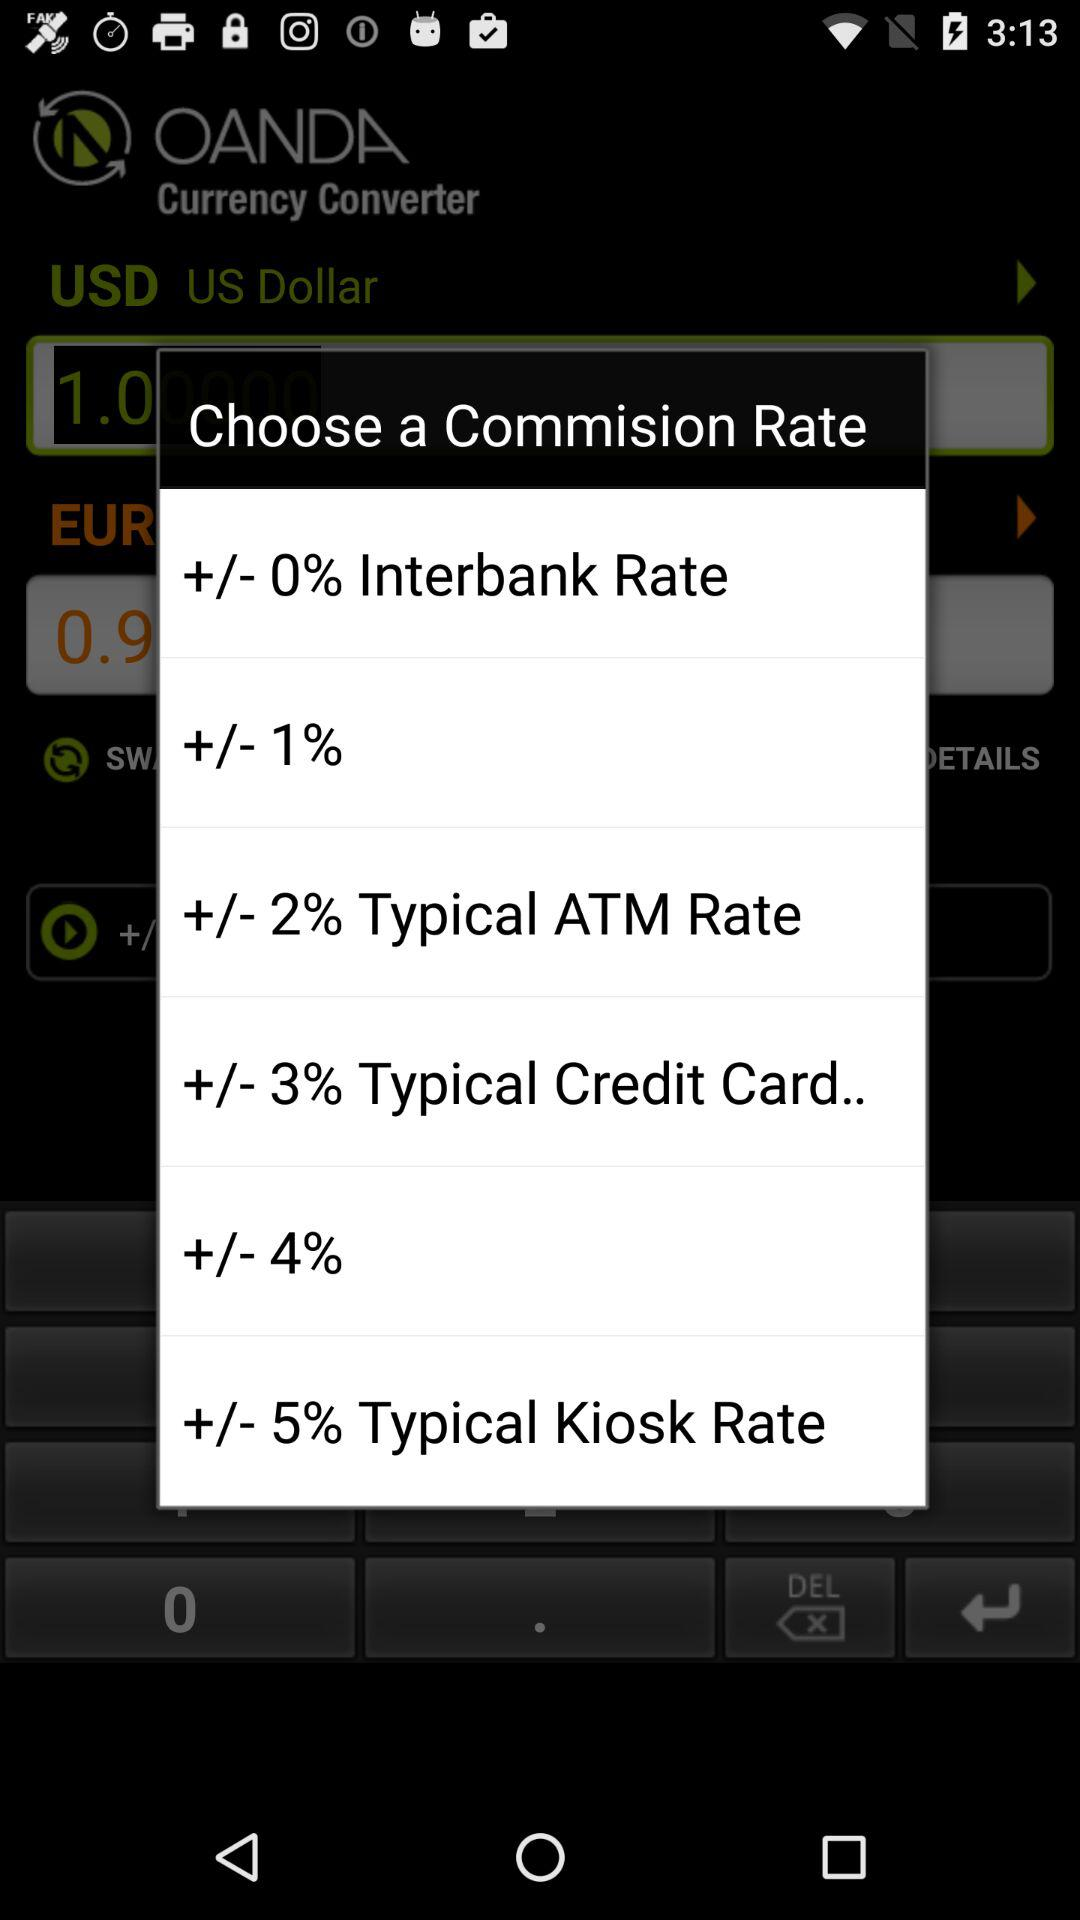What is the commission rate for "ATM rate"? The commission rate is "+/- 2%". 